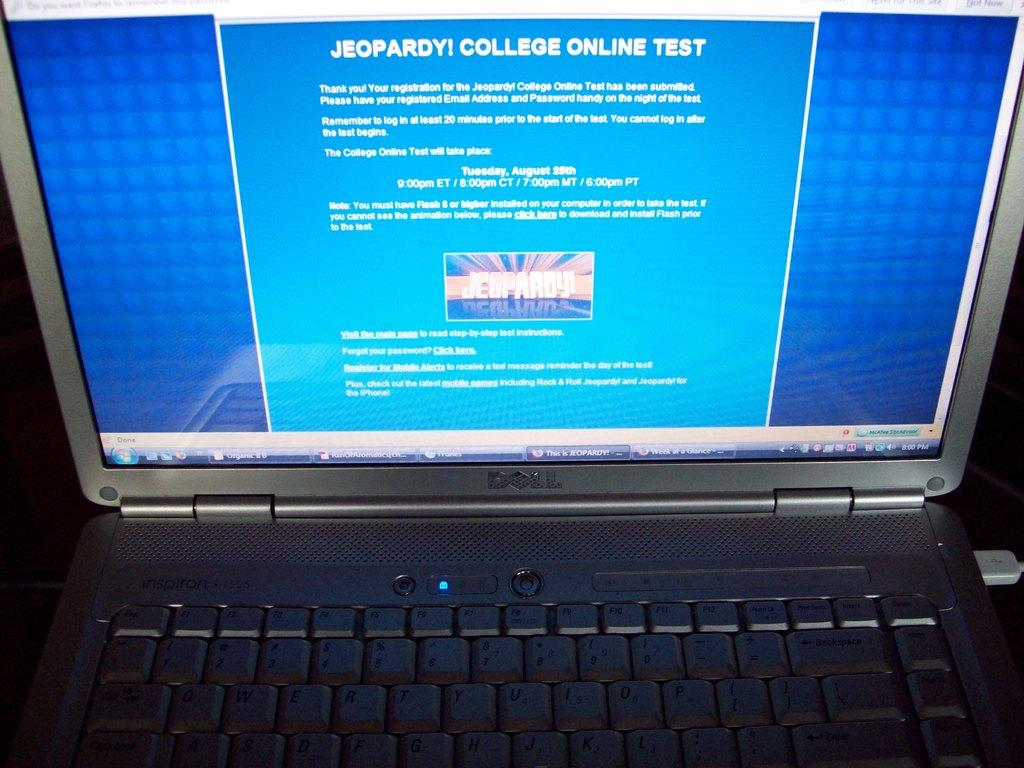Provide a one-sentence caption for the provided image. Jeopardy, College Online Test is the header of the site shown on this laptop. 